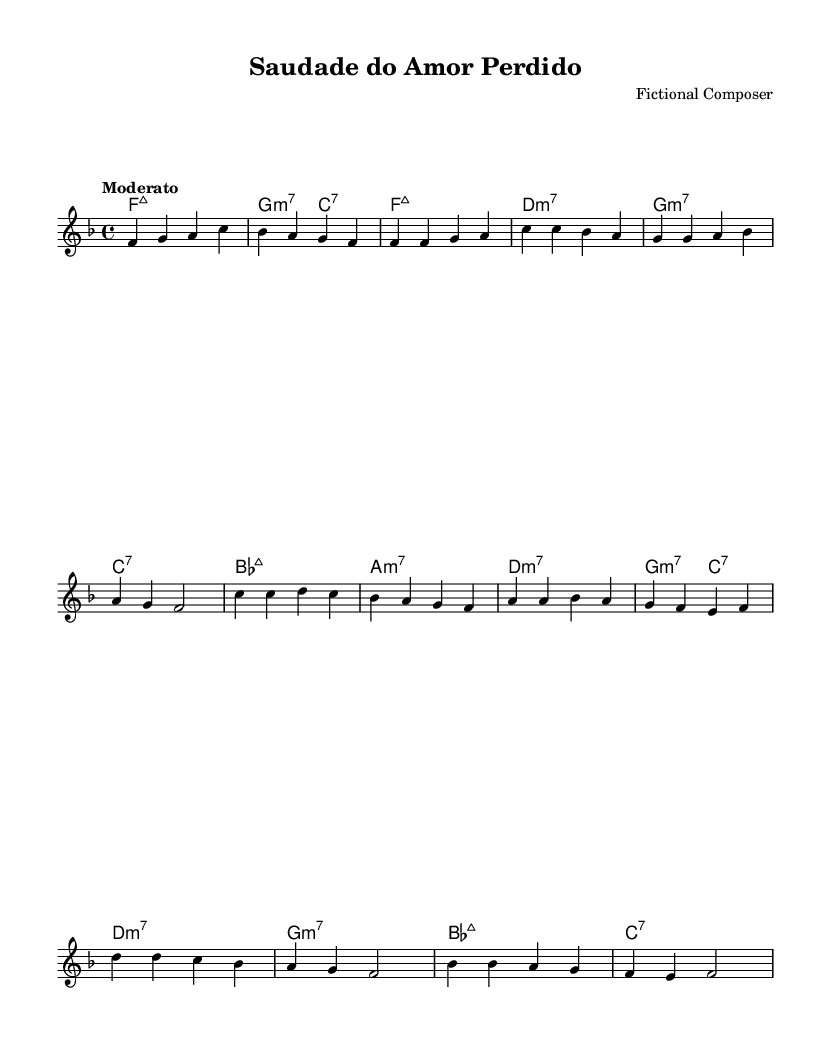What is the key signature of this music? The key signature is F major, which has one flat (B flat). This can be identified by looking at the key signature at the beginning of the staff.
Answer: F major What is the time signature of this music? The time signature is 4/4, indicated at the beginning of the sheet music. In 4/4 time, there are four beats in each measure, and each quarter note gets one beat.
Answer: 4/4 What is the tempo marking for this piece? The tempo marking is "Moderato," which suggests a moderate speed for the performance. This can be found near the beginning of the sheet music, indicating the intended pace.
Answer: Moderato How many measures are in the verse section of the song? The verse section consists of four measures. This can be determined by counting the measures in the designated verse section of the melody.
Answer: 4 What is the first chord in the song? The first chord is F major 7. This is located in the harmonies section and is the first entry, followed by the second chord in the intro.
Answer: F major 7 Which section contains the highest note in the melody? The bridge section contains the highest note, which is D. Looking through the melody, the highest pitch in the bridge subsection is noted as D in the first measure of that section.
Answer: D What type of musical piece is this? This piece is a Bossa Nova song. The characteristics, including its rhythmic style and use of harmony, are typical elements of the Bossa Nova genre.
Answer: Bossa Nova 